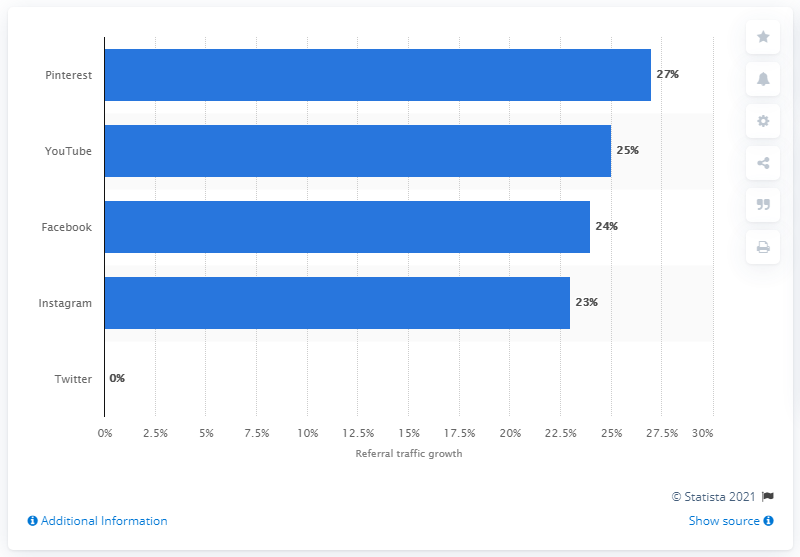Mention a couple of crucial points in this snapshot. Instagram's referral traffic increased by 23% in the fourth quarter of 2019. 